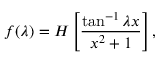Convert formula to latex. <formula><loc_0><loc_0><loc_500><loc_500>f ( \lambda ) = H \left [ \frac { \tan ^ { - 1 } \lambda x } { x ^ { 2 } + 1 } \right ] ,</formula> 